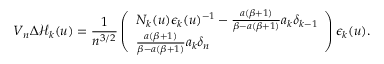Convert formula to latex. <formula><loc_0><loc_0><loc_500><loc_500>V _ { n } \Delta \mathcal { H } _ { k } ( u ) = \frac { 1 } { n ^ { 3 / 2 } } \left ( \begin{array} { l } { N _ { k } ( u ) \epsilon _ { k } ( u ) ^ { - 1 } - \frac { a ( \beta + 1 ) } { \beta - a ( \beta + 1 ) } a _ { k } \delta _ { k - 1 } } \\ { \frac { a ( \beta + 1 ) } { \beta - a ( \beta + 1 ) } a _ { k } \delta _ { n } } \end{array} \right ) \epsilon _ { k } ( u ) .</formula> 